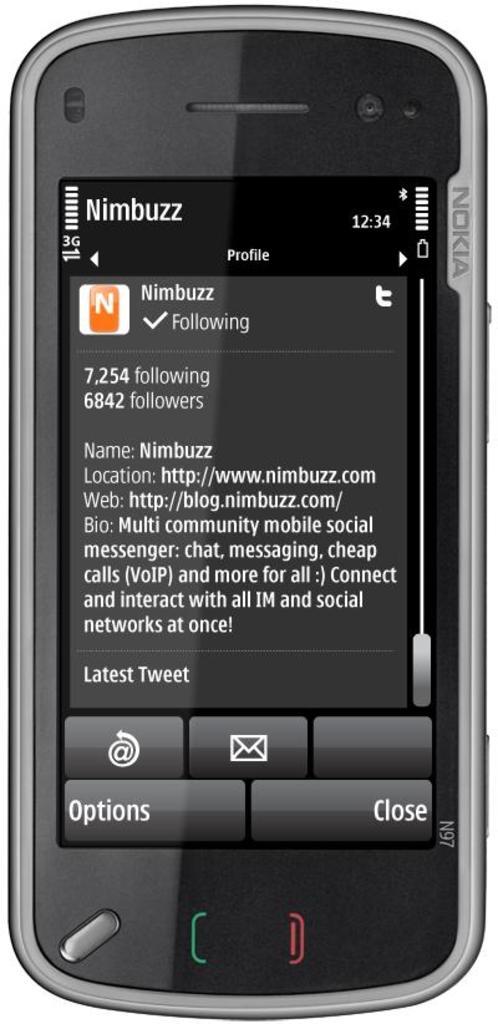Where is the "options" button?
Give a very brief answer. Bottom left. What is written on the bottom right of the screen?
Provide a succinct answer. Close. 